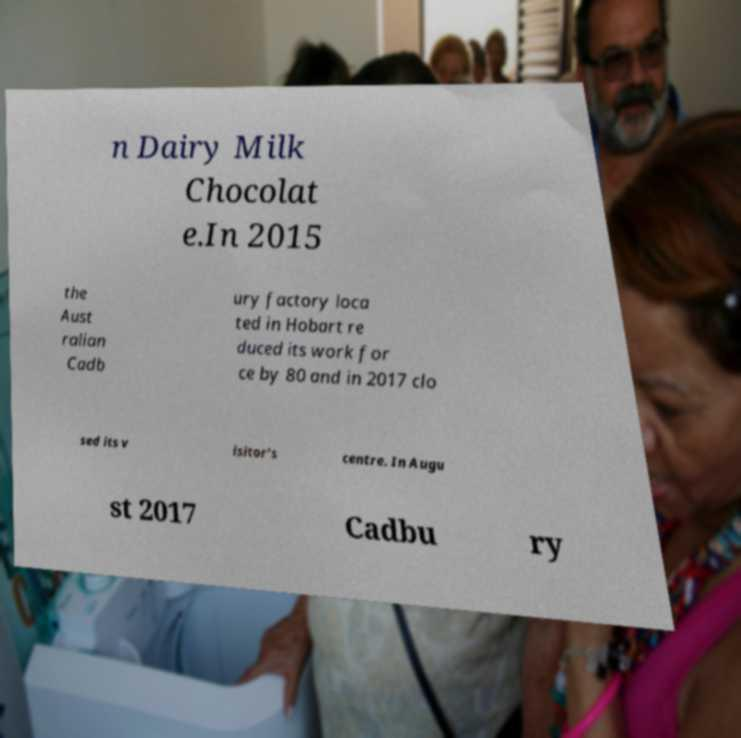Could you extract and type out the text from this image? n Dairy Milk Chocolat e.In 2015 the Aust ralian Cadb ury factory loca ted in Hobart re duced its work for ce by 80 and in 2017 clo sed its v isitor's centre. In Augu st 2017 Cadbu ry 